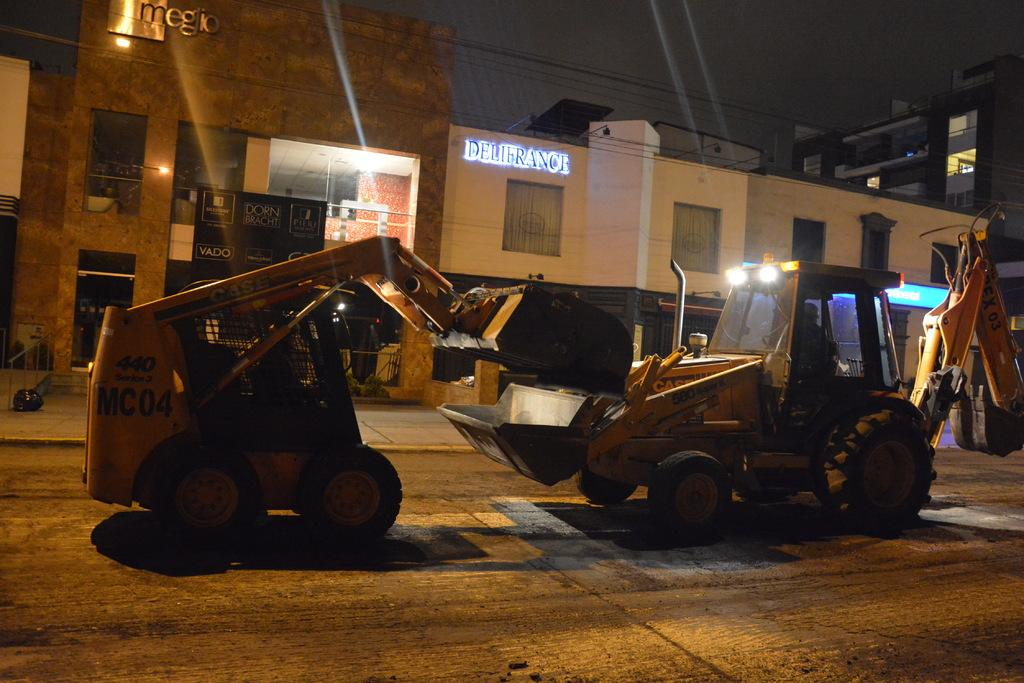<image>
Present a compact description of the photo's key features. the word delifrance that is on a building 